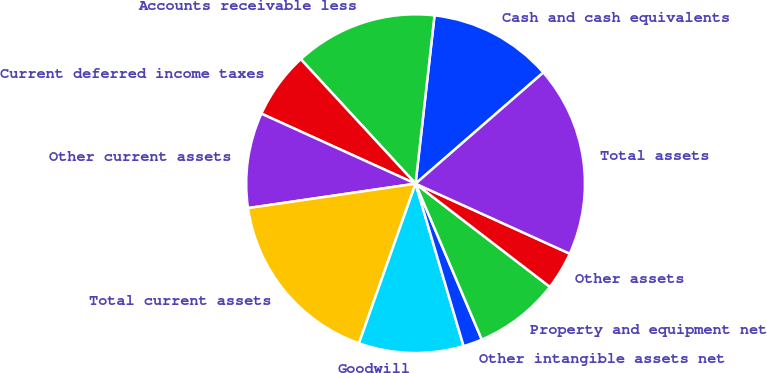Convert chart to OTSL. <chart><loc_0><loc_0><loc_500><loc_500><pie_chart><fcel>Cash and cash equivalents<fcel>Accounts receivable less<fcel>Current deferred income taxes<fcel>Other current assets<fcel>Total current assets<fcel>Goodwill<fcel>Other intangible assets net<fcel>Property and equipment net<fcel>Other assets<fcel>Total assets<nl><fcel>11.82%<fcel>13.64%<fcel>6.36%<fcel>9.09%<fcel>17.27%<fcel>10.0%<fcel>1.82%<fcel>8.18%<fcel>3.64%<fcel>18.18%<nl></chart> 